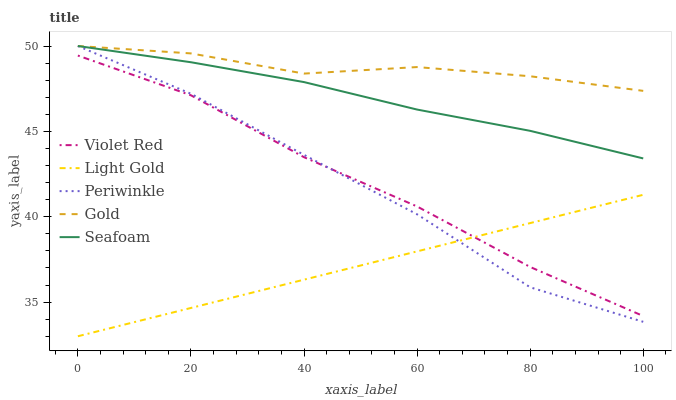Does Violet Red have the minimum area under the curve?
Answer yes or no. No. Does Violet Red have the maximum area under the curve?
Answer yes or no. No. Is Violet Red the smoothest?
Answer yes or no. No. Is Violet Red the roughest?
Answer yes or no. No. Does Violet Red have the lowest value?
Answer yes or no. No. Does Violet Red have the highest value?
Answer yes or no. No. Is Violet Red less than Seafoam?
Answer yes or no. Yes. Is Gold greater than Light Gold?
Answer yes or no. Yes. Does Violet Red intersect Seafoam?
Answer yes or no. No. 